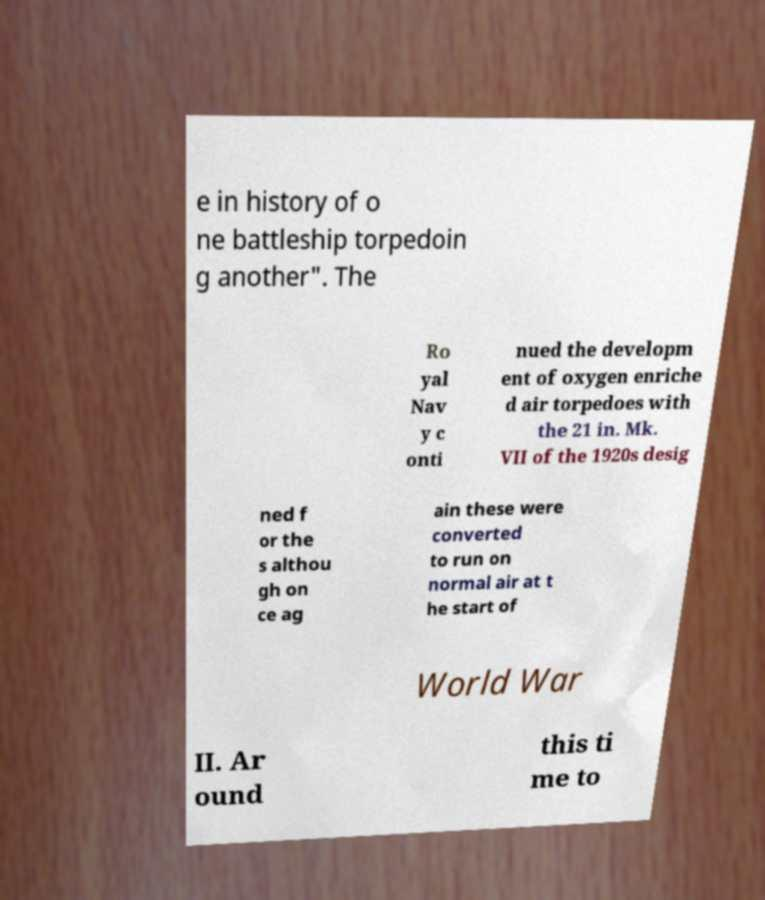What messages or text are displayed in this image? I need them in a readable, typed format. e in history of o ne battleship torpedoin g another". The Ro yal Nav y c onti nued the developm ent of oxygen enriche d air torpedoes with the 21 in. Mk. VII of the 1920s desig ned f or the s althou gh on ce ag ain these were converted to run on normal air at t he start of World War II. Ar ound this ti me to 